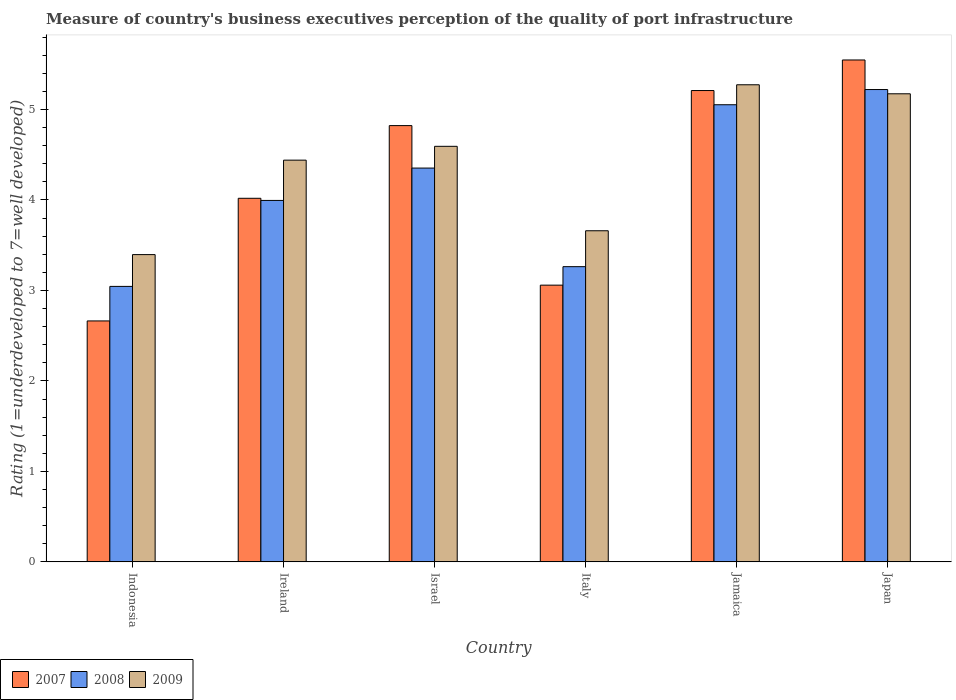How many different coloured bars are there?
Keep it short and to the point. 3. Are the number of bars on each tick of the X-axis equal?
Ensure brevity in your answer.  Yes. How many bars are there on the 3rd tick from the left?
Your answer should be very brief. 3. What is the ratings of the quality of port infrastructure in 2007 in Indonesia?
Offer a terse response. 2.66. Across all countries, what is the maximum ratings of the quality of port infrastructure in 2009?
Your response must be concise. 5.27. Across all countries, what is the minimum ratings of the quality of port infrastructure in 2009?
Make the answer very short. 3.4. In which country was the ratings of the quality of port infrastructure in 2009 maximum?
Your response must be concise. Jamaica. What is the total ratings of the quality of port infrastructure in 2009 in the graph?
Give a very brief answer. 26.54. What is the difference between the ratings of the quality of port infrastructure in 2007 in Indonesia and that in Japan?
Keep it short and to the point. -2.88. What is the difference between the ratings of the quality of port infrastructure in 2008 in Ireland and the ratings of the quality of port infrastructure in 2009 in Japan?
Provide a succinct answer. -1.18. What is the average ratings of the quality of port infrastructure in 2007 per country?
Your answer should be very brief. 4.22. What is the difference between the ratings of the quality of port infrastructure of/in 2008 and ratings of the quality of port infrastructure of/in 2009 in Jamaica?
Make the answer very short. -0.22. In how many countries, is the ratings of the quality of port infrastructure in 2009 greater than 3.6?
Provide a succinct answer. 5. What is the ratio of the ratings of the quality of port infrastructure in 2007 in Ireland to that in Japan?
Make the answer very short. 0.72. Is the difference between the ratings of the quality of port infrastructure in 2008 in Italy and Jamaica greater than the difference between the ratings of the quality of port infrastructure in 2009 in Italy and Jamaica?
Provide a succinct answer. No. What is the difference between the highest and the second highest ratings of the quality of port infrastructure in 2007?
Keep it short and to the point. 0.39. What is the difference between the highest and the lowest ratings of the quality of port infrastructure in 2009?
Give a very brief answer. 1.88. Is the sum of the ratings of the quality of port infrastructure in 2009 in Indonesia and Jamaica greater than the maximum ratings of the quality of port infrastructure in 2007 across all countries?
Offer a very short reply. Yes. What does the 2nd bar from the right in Japan represents?
Keep it short and to the point. 2008. How many bars are there?
Your answer should be very brief. 18. Are all the bars in the graph horizontal?
Provide a short and direct response. No. What is the difference between two consecutive major ticks on the Y-axis?
Offer a terse response. 1. Are the values on the major ticks of Y-axis written in scientific E-notation?
Your response must be concise. No. Does the graph contain grids?
Your response must be concise. No. Where does the legend appear in the graph?
Provide a succinct answer. Bottom left. How are the legend labels stacked?
Make the answer very short. Horizontal. What is the title of the graph?
Provide a succinct answer. Measure of country's business executives perception of the quality of port infrastructure. What is the label or title of the X-axis?
Make the answer very short. Country. What is the label or title of the Y-axis?
Ensure brevity in your answer.  Rating (1=underdeveloped to 7=well developed). What is the Rating (1=underdeveloped to 7=well developed) in 2007 in Indonesia?
Offer a terse response. 2.66. What is the Rating (1=underdeveloped to 7=well developed) in 2008 in Indonesia?
Provide a succinct answer. 3.04. What is the Rating (1=underdeveloped to 7=well developed) in 2009 in Indonesia?
Provide a succinct answer. 3.4. What is the Rating (1=underdeveloped to 7=well developed) of 2007 in Ireland?
Make the answer very short. 4.02. What is the Rating (1=underdeveloped to 7=well developed) of 2008 in Ireland?
Make the answer very short. 4. What is the Rating (1=underdeveloped to 7=well developed) of 2009 in Ireland?
Your response must be concise. 4.44. What is the Rating (1=underdeveloped to 7=well developed) of 2007 in Israel?
Offer a terse response. 4.82. What is the Rating (1=underdeveloped to 7=well developed) of 2008 in Israel?
Provide a short and direct response. 4.35. What is the Rating (1=underdeveloped to 7=well developed) in 2009 in Israel?
Your answer should be very brief. 4.59. What is the Rating (1=underdeveloped to 7=well developed) in 2007 in Italy?
Your response must be concise. 3.06. What is the Rating (1=underdeveloped to 7=well developed) of 2008 in Italy?
Your response must be concise. 3.26. What is the Rating (1=underdeveloped to 7=well developed) in 2009 in Italy?
Offer a terse response. 3.66. What is the Rating (1=underdeveloped to 7=well developed) in 2007 in Jamaica?
Provide a short and direct response. 5.21. What is the Rating (1=underdeveloped to 7=well developed) in 2008 in Jamaica?
Your answer should be compact. 5.05. What is the Rating (1=underdeveloped to 7=well developed) of 2009 in Jamaica?
Keep it short and to the point. 5.27. What is the Rating (1=underdeveloped to 7=well developed) of 2007 in Japan?
Keep it short and to the point. 5.55. What is the Rating (1=underdeveloped to 7=well developed) in 2008 in Japan?
Your answer should be compact. 5.22. What is the Rating (1=underdeveloped to 7=well developed) of 2009 in Japan?
Provide a succinct answer. 5.17. Across all countries, what is the maximum Rating (1=underdeveloped to 7=well developed) in 2007?
Make the answer very short. 5.55. Across all countries, what is the maximum Rating (1=underdeveloped to 7=well developed) of 2008?
Offer a terse response. 5.22. Across all countries, what is the maximum Rating (1=underdeveloped to 7=well developed) in 2009?
Offer a terse response. 5.27. Across all countries, what is the minimum Rating (1=underdeveloped to 7=well developed) of 2007?
Ensure brevity in your answer.  2.66. Across all countries, what is the minimum Rating (1=underdeveloped to 7=well developed) in 2008?
Keep it short and to the point. 3.04. Across all countries, what is the minimum Rating (1=underdeveloped to 7=well developed) in 2009?
Provide a short and direct response. 3.4. What is the total Rating (1=underdeveloped to 7=well developed) of 2007 in the graph?
Offer a terse response. 25.32. What is the total Rating (1=underdeveloped to 7=well developed) in 2008 in the graph?
Ensure brevity in your answer.  24.93. What is the total Rating (1=underdeveloped to 7=well developed) of 2009 in the graph?
Keep it short and to the point. 26.54. What is the difference between the Rating (1=underdeveloped to 7=well developed) in 2007 in Indonesia and that in Ireland?
Offer a very short reply. -1.36. What is the difference between the Rating (1=underdeveloped to 7=well developed) in 2008 in Indonesia and that in Ireland?
Give a very brief answer. -0.95. What is the difference between the Rating (1=underdeveloped to 7=well developed) of 2009 in Indonesia and that in Ireland?
Your response must be concise. -1.04. What is the difference between the Rating (1=underdeveloped to 7=well developed) of 2007 in Indonesia and that in Israel?
Your answer should be compact. -2.16. What is the difference between the Rating (1=underdeveloped to 7=well developed) in 2008 in Indonesia and that in Israel?
Provide a succinct answer. -1.31. What is the difference between the Rating (1=underdeveloped to 7=well developed) in 2009 in Indonesia and that in Israel?
Your response must be concise. -1.2. What is the difference between the Rating (1=underdeveloped to 7=well developed) of 2007 in Indonesia and that in Italy?
Offer a terse response. -0.4. What is the difference between the Rating (1=underdeveloped to 7=well developed) of 2008 in Indonesia and that in Italy?
Offer a very short reply. -0.22. What is the difference between the Rating (1=underdeveloped to 7=well developed) of 2009 in Indonesia and that in Italy?
Keep it short and to the point. -0.26. What is the difference between the Rating (1=underdeveloped to 7=well developed) of 2007 in Indonesia and that in Jamaica?
Provide a short and direct response. -2.55. What is the difference between the Rating (1=underdeveloped to 7=well developed) in 2008 in Indonesia and that in Jamaica?
Your answer should be compact. -2.01. What is the difference between the Rating (1=underdeveloped to 7=well developed) of 2009 in Indonesia and that in Jamaica?
Ensure brevity in your answer.  -1.88. What is the difference between the Rating (1=underdeveloped to 7=well developed) of 2007 in Indonesia and that in Japan?
Provide a succinct answer. -2.88. What is the difference between the Rating (1=underdeveloped to 7=well developed) of 2008 in Indonesia and that in Japan?
Make the answer very short. -2.18. What is the difference between the Rating (1=underdeveloped to 7=well developed) of 2009 in Indonesia and that in Japan?
Make the answer very short. -1.78. What is the difference between the Rating (1=underdeveloped to 7=well developed) in 2007 in Ireland and that in Israel?
Ensure brevity in your answer.  -0.8. What is the difference between the Rating (1=underdeveloped to 7=well developed) of 2008 in Ireland and that in Israel?
Give a very brief answer. -0.36. What is the difference between the Rating (1=underdeveloped to 7=well developed) of 2009 in Ireland and that in Israel?
Your answer should be very brief. -0.15. What is the difference between the Rating (1=underdeveloped to 7=well developed) of 2007 in Ireland and that in Italy?
Offer a terse response. 0.96. What is the difference between the Rating (1=underdeveloped to 7=well developed) of 2008 in Ireland and that in Italy?
Your answer should be very brief. 0.73. What is the difference between the Rating (1=underdeveloped to 7=well developed) in 2009 in Ireland and that in Italy?
Give a very brief answer. 0.78. What is the difference between the Rating (1=underdeveloped to 7=well developed) in 2007 in Ireland and that in Jamaica?
Your answer should be compact. -1.19. What is the difference between the Rating (1=underdeveloped to 7=well developed) in 2008 in Ireland and that in Jamaica?
Provide a succinct answer. -1.06. What is the difference between the Rating (1=underdeveloped to 7=well developed) of 2009 in Ireland and that in Jamaica?
Keep it short and to the point. -0.83. What is the difference between the Rating (1=underdeveloped to 7=well developed) in 2007 in Ireland and that in Japan?
Offer a terse response. -1.53. What is the difference between the Rating (1=underdeveloped to 7=well developed) of 2008 in Ireland and that in Japan?
Your response must be concise. -1.23. What is the difference between the Rating (1=underdeveloped to 7=well developed) of 2009 in Ireland and that in Japan?
Give a very brief answer. -0.73. What is the difference between the Rating (1=underdeveloped to 7=well developed) in 2007 in Israel and that in Italy?
Provide a short and direct response. 1.76. What is the difference between the Rating (1=underdeveloped to 7=well developed) of 2008 in Israel and that in Italy?
Your answer should be compact. 1.09. What is the difference between the Rating (1=underdeveloped to 7=well developed) in 2009 in Israel and that in Italy?
Your answer should be very brief. 0.93. What is the difference between the Rating (1=underdeveloped to 7=well developed) of 2007 in Israel and that in Jamaica?
Provide a succinct answer. -0.39. What is the difference between the Rating (1=underdeveloped to 7=well developed) of 2008 in Israel and that in Jamaica?
Ensure brevity in your answer.  -0.7. What is the difference between the Rating (1=underdeveloped to 7=well developed) in 2009 in Israel and that in Jamaica?
Your response must be concise. -0.68. What is the difference between the Rating (1=underdeveloped to 7=well developed) of 2007 in Israel and that in Japan?
Your response must be concise. -0.73. What is the difference between the Rating (1=underdeveloped to 7=well developed) of 2008 in Israel and that in Japan?
Keep it short and to the point. -0.87. What is the difference between the Rating (1=underdeveloped to 7=well developed) of 2009 in Israel and that in Japan?
Make the answer very short. -0.58. What is the difference between the Rating (1=underdeveloped to 7=well developed) of 2007 in Italy and that in Jamaica?
Provide a short and direct response. -2.15. What is the difference between the Rating (1=underdeveloped to 7=well developed) in 2008 in Italy and that in Jamaica?
Provide a short and direct response. -1.79. What is the difference between the Rating (1=underdeveloped to 7=well developed) of 2009 in Italy and that in Jamaica?
Your answer should be compact. -1.61. What is the difference between the Rating (1=underdeveloped to 7=well developed) in 2007 in Italy and that in Japan?
Make the answer very short. -2.49. What is the difference between the Rating (1=underdeveloped to 7=well developed) in 2008 in Italy and that in Japan?
Make the answer very short. -1.96. What is the difference between the Rating (1=underdeveloped to 7=well developed) in 2009 in Italy and that in Japan?
Offer a very short reply. -1.51. What is the difference between the Rating (1=underdeveloped to 7=well developed) in 2007 in Jamaica and that in Japan?
Provide a succinct answer. -0.34. What is the difference between the Rating (1=underdeveloped to 7=well developed) of 2008 in Jamaica and that in Japan?
Your response must be concise. -0.17. What is the difference between the Rating (1=underdeveloped to 7=well developed) of 2009 in Jamaica and that in Japan?
Offer a terse response. 0.1. What is the difference between the Rating (1=underdeveloped to 7=well developed) of 2007 in Indonesia and the Rating (1=underdeveloped to 7=well developed) of 2008 in Ireland?
Provide a succinct answer. -1.33. What is the difference between the Rating (1=underdeveloped to 7=well developed) of 2007 in Indonesia and the Rating (1=underdeveloped to 7=well developed) of 2009 in Ireland?
Your response must be concise. -1.78. What is the difference between the Rating (1=underdeveloped to 7=well developed) of 2008 in Indonesia and the Rating (1=underdeveloped to 7=well developed) of 2009 in Ireland?
Make the answer very short. -1.4. What is the difference between the Rating (1=underdeveloped to 7=well developed) in 2007 in Indonesia and the Rating (1=underdeveloped to 7=well developed) in 2008 in Israel?
Provide a short and direct response. -1.69. What is the difference between the Rating (1=underdeveloped to 7=well developed) of 2007 in Indonesia and the Rating (1=underdeveloped to 7=well developed) of 2009 in Israel?
Ensure brevity in your answer.  -1.93. What is the difference between the Rating (1=underdeveloped to 7=well developed) in 2008 in Indonesia and the Rating (1=underdeveloped to 7=well developed) in 2009 in Israel?
Give a very brief answer. -1.55. What is the difference between the Rating (1=underdeveloped to 7=well developed) of 2007 in Indonesia and the Rating (1=underdeveloped to 7=well developed) of 2008 in Italy?
Your answer should be very brief. -0.6. What is the difference between the Rating (1=underdeveloped to 7=well developed) in 2007 in Indonesia and the Rating (1=underdeveloped to 7=well developed) in 2009 in Italy?
Make the answer very short. -1. What is the difference between the Rating (1=underdeveloped to 7=well developed) of 2008 in Indonesia and the Rating (1=underdeveloped to 7=well developed) of 2009 in Italy?
Provide a succinct answer. -0.61. What is the difference between the Rating (1=underdeveloped to 7=well developed) of 2007 in Indonesia and the Rating (1=underdeveloped to 7=well developed) of 2008 in Jamaica?
Your answer should be very brief. -2.39. What is the difference between the Rating (1=underdeveloped to 7=well developed) in 2007 in Indonesia and the Rating (1=underdeveloped to 7=well developed) in 2009 in Jamaica?
Offer a terse response. -2.61. What is the difference between the Rating (1=underdeveloped to 7=well developed) of 2008 in Indonesia and the Rating (1=underdeveloped to 7=well developed) of 2009 in Jamaica?
Ensure brevity in your answer.  -2.23. What is the difference between the Rating (1=underdeveloped to 7=well developed) in 2007 in Indonesia and the Rating (1=underdeveloped to 7=well developed) in 2008 in Japan?
Your answer should be very brief. -2.56. What is the difference between the Rating (1=underdeveloped to 7=well developed) in 2007 in Indonesia and the Rating (1=underdeveloped to 7=well developed) in 2009 in Japan?
Provide a short and direct response. -2.51. What is the difference between the Rating (1=underdeveloped to 7=well developed) in 2008 in Indonesia and the Rating (1=underdeveloped to 7=well developed) in 2009 in Japan?
Provide a succinct answer. -2.13. What is the difference between the Rating (1=underdeveloped to 7=well developed) in 2007 in Ireland and the Rating (1=underdeveloped to 7=well developed) in 2008 in Israel?
Provide a short and direct response. -0.33. What is the difference between the Rating (1=underdeveloped to 7=well developed) of 2007 in Ireland and the Rating (1=underdeveloped to 7=well developed) of 2009 in Israel?
Offer a very short reply. -0.57. What is the difference between the Rating (1=underdeveloped to 7=well developed) in 2008 in Ireland and the Rating (1=underdeveloped to 7=well developed) in 2009 in Israel?
Offer a terse response. -0.6. What is the difference between the Rating (1=underdeveloped to 7=well developed) in 2007 in Ireland and the Rating (1=underdeveloped to 7=well developed) in 2008 in Italy?
Give a very brief answer. 0.76. What is the difference between the Rating (1=underdeveloped to 7=well developed) of 2007 in Ireland and the Rating (1=underdeveloped to 7=well developed) of 2009 in Italy?
Offer a terse response. 0.36. What is the difference between the Rating (1=underdeveloped to 7=well developed) of 2008 in Ireland and the Rating (1=underdeveloped to 7=well developed) of 2009 in Italy?
Your response must be concise. 0.34. What is the difference between the Rating (1=underdeveloped to 7=well developed) of 2007 in Ireland and the Rating (1=underdeveloped to 7=well developed) of 2008 in Jamaica?
Give a very brief answer. -1.03. What is the difference between the Rating (1=underdeveloped to 7=well developed) of 2007 in Ireland and the Rating (1=underdeveloped to 7=well developed) of 2009 in Jamaica?
Give a very brief answer. -1.25. What is the difference between the Rating (1=underdeveloped to 7=well developed) of 2008 in Ireland and the Rating (1=underdeveloped to 7=well developed) of 2009 in Jamaica?
Provide a short and direct response. -1.28. What is the difference between the Rating (1=underdeveloped to 7=well developed) of 2007 in Ireland and the Rating (1=underdeveloped to 7=well developed) of 2008 in Japan?
Provide a succinct answer. -1.2. What is the difference between the Rating (1=underdeveloped to 7=well developed) of 2007 in Ireland and the Rating (1=underdeveloped to 7=well developed) of 2009 in Japan?
Your answer should be very brief. -1.16. What is the difference between the Rating (1=underdeveloped to 7=well developed) of 2008 in Ireland and the Rating (1=underdeveloped to 7=well developed) of 2009 in Japan?
Keep it short and to the point. -1.18. What is the difference between the Rating (1=underdeveloped to 7=well developed) of 2007 in Israel and the Rating (1=underdeveloped to 7=well developed) of 2008 in Italy?
Ensure brevity in your answer.  1.56. What is the difference between the Rating (1=underdeveloped to 7=well developed) in 2007 in Israel and the Rating (1=underdeveloped to 7=well developed) in 2009 in Italy?
Provide a succinct answer. 1.16. What is the difference between the Rating (1=underdeveloped to 7=well developed) in 2008 in Israel and the Rating (1=underdeveloped to 7=well developed) in 2009 in Italy?
Your answer should be compact. 0.69. What is the difference between the Rating (1=underdeveloped to 7=well developed) of 2007 in Israel and the Rating (1=underdeveloped to 7=well developed) of 2008 in Jamaica?
Your answer should be compact. -0.23. What is the difference between the Rating (1=underdeveloped to 7=well developed) in 2007 in Israel and the Rating (1=underdeveloped to 7=well developed) in 2009 in Jamaica?
Your answer should be very brief. -0.45. What is the difference between the Rating (1=underdeveloped to 7=well developed) of 2008 in Israel and the Rating (1=underdeveloped to 7=well developed) of 2009 in Jamaica?
Provide a succinct answer. -0.92. What is the difference between the Rating (1=underdeveloped to 7=well developed) of 2007 in Israel and the Rating (1=underdeveloped to 7=well developed) of 2008 in Japan?
Your answer should be very brief. -0.4. What is the difference between the Rating (1=underdeveloped to 7=well developed) of 2007 in Israel and the Rating (1=underdeveloped to 7=well developed) of 2009 in Japan?
Provide a short and direct response. -0.35. What is the difference between the Rating (1=underdeveloped to 7=well developed) in 2008 in Israel and the Rating (1=underdeveloped to 7=well developed) in 2009 in Japan?
Make the answer very short. -0.82. What is the difference between the Rating (1=underdeveloped to 7=well developed) in 2007 in Italy and the Rating (1=underdeveloped to 7=well developed) in 2008 in Jamaica?
Give a very brief answer. -1.99. What is the difference between the Rating (1=underdeveloped to 7=well developed) of 2007 in Italy and the Rating (1=underdeveloped to 7=well developed) of 2009 in Jamaica?
Keep it short and to the point. -2.21. What is the difference between the Rating (1=underdeveloped to 7=well developed) of 2008 in Italy and the Rating (1=underdeveloped to 7=well developed) of 2009 in Jamaica?
Give a very brief answer. -2.01. What is the difference between the Rating (1=underdeveloped to 7=well developed) of 2007 in Italy and the Rating (1=underdeveloped to 7=well developed) of 2008 in Japan?
Offer a terse response. -2.16. What is the difference between the Rating (1=underdeveloped to 7=well developed) in 2007 in Italy and the Rating (1=underdeveloped to 7=well developed) in 2009 in Japan?
Make the answer very short. -2.12. What is the difference between the Rating (1=underdeveloped to 7=well developed) of 2008 in Italy and the Rating (1=underdeveloped to 7=well developed) of 2009 in Japan?
Offer a terse response. -1.91. What is the difference between the Rating (1=underdeveloped to 7=well developed) in 2007 in Jamaica and the Rating (1=underdeveloped to 7=well developed) in 2008 in Japan?
Offer a very short reply. -0.01. What is the difference between the Rating (1=underdeveloped to 7=well developed) of 2007 in Jamaica and the Rating (1=underdeveloped to 7=well developed) of 2009 in Japan?
Your answer should be compact. 0.04. What is the difference between the Rating (1=underdeveloped to 7=well developed) in 2008 in Jamaica and the Rating (1=underdeveloped to 7=well developed) in 2009 in Japan?
Your answer should be very brief. -0.12. What is the average Rating (1=underdeveloped to 7=well developed) of 2007 per country?
Your response must be concise. 4.22. What is the average Rating (1=underdeveloped to 7=well developed) of 2008 per country?
Offer a terse response. 4.15. What is the average Rating (1=underdeveloped to 7=well developed) in 2009 per country?
Offer a terse response. 4.42. What is the difference between the Rating (1=underdeveloped to 7=well developed) in 2007 and Rating (1=underdeveloped to 7=well developed) in 2008 in Indonesia?
Keep it short and to the point. -0.38. What is the difference between the Rating (1=underdeveloped to 7=well developed) of 2007 and Rating (1=underdeveloped to 7=well developed) of 2009 in Indonesia?
Keep it short and to the point. -0.73. What is the difference between the Rating (1=underdeveloped to 7=well developed) of 2008 and Rating (1=underdeveloped to 7=well developed) of 2009 in Indonesia?
Your answer should be very brief. -0.35. What is the difference between the Rating (1=underdeveloped to 7=well developed) in 2007 and Rating (1=underdeveloped to 7=well developed) in 2008 in Ireland?
Your answer should be compact. 0.02. What is the difference between the Rating (1=underdeveloped to 7=well developed) in 2007 and Rating (1=underdeveloped to 7=well developed) in 2009 in Ireland?
Offer a very short reply. -0.42. What is the difference between the Rating (1=underdeveloped to 7=well developed) in 2008 and Rating (1=underdeveloped to 7=well developed) in 2009 in Ireland?
Provide a short and direct response. -0.45. What is the difference between the Rating (1=underdeveloped to 7=well developed) of 2007 and Rating (1=underdeveloped to 7=well developed) of 2008 in Israel?
Ensure brevity in your answer.  0.47. What is the difference between the Rating (1=underdeveloped to 7=well developed) of 2007 and Rating (1=underdeveloped to 7=well developed) of 2009 in Israel?
Keep it short and to the point. 0.23. What is the difference between the Rating (1=underdeveloped to 7=well developed) of 2008 and Rating (1=underdeveloped to 7=well developed) of 2009 in Israel?
Provide a short and direct response. -0.24. What is the difference between the Rating (1=underdeveloped to 7=well developed) of 2007 and Rating (1=underdeveloped to 7=well developed) of 2008 in Italy?
Offer a very short reply. -0.2. What is the difference between the Rating (1=underdeveloped to 7=well developed) of 2007 and Rating (1=underdeveloped to 7=well developed) of 2009 in Italy?
Your answer should be very brief. -0.6. What is the difference between the Rating (1=underdeveloped to 7=well developed) of 2008 and Rating (1=underdeveloped to 7=well developed) of 2009 in Italy?
Your answer should be compact. -0.4. What is the difference between the Rating (1=underdeveloped to 7=well developed) of 2007 and Rating (1=underdeveloped to 7=well developed) of 2008 in Jamaica?
Make the answer very short. 0.16. What is the difference between the Rating (1=underdeveloped to 7=well developed) in 2007 and Rating (1=underdeveloped to 7=well developed) in 2009 in Jamaica?
Provide a short and direct response. -0.06. What is the difference between the Rating (1=underdeveloped to 7=well developed) of 2008 and Rating (1=underdeveloped to 7=well developed) of 2009 in Jamaica?
Ensure brevity in your answer.  -0.22. What is the difference between the Rating (1=underdeveloped to 7=well developed) in 2007 and Rating (1=underdeveloped to 7=well developed) in 2008 in Japan?
Make the answer very short. 0.33. What is the difference between the Rating (1=underdeveloped to 7=well developed) of 2007 and Rating (1=underdeveloped to 7=well developed) of 2009 in Japan?
Make the answer very short. 0.37. What is the difference between the Rating (1=underdeveloped to 7=well developed) in 2008 and Rating (1=underdeveloped to 7=well developed) in 2009 in Japan?
Your answer should be compact. 0.05. What is the ratio of the Rating (1=underdeveloped to 7=well developed) of 2007 in Indonesia to that in Ireland?
Make the answer very short. 0.66. What is the ratio of the Rating (1=underdeveloped to 7=well developed) in 2008 in Indonesia to that in Ireland?
Your answer should be very brief. 0.76. What is the ratio of the Rating (1=underdeveloped to 7=well developed) in 2009 in Indonesia to that in Ireland?
Provide a short and direct response. 0.76. What is the ratio of the Rating (1=underdeveloped to 7=well developed) in 2007 in Indonesia to that in Israel?
Provide a short and direct response. 0.55. What is the ratio of the Rating (1=underdeveloped to 7=well developed) in 2008 in Indonesia to that in Israel?
Provide a succinct answer. 0.7. What is the ratio of the Rating (1=underdeveloped to 7=well developed) in 2009 in Indonesia to that in Israel?
Your answer should be very brief. 0.74. What is the ratio of the Rating (1=underdeveloped to 7=well developed) in 2007 in Indonesia to that in Italy?
Your answer should be very brief. 0.87. What is the ratio of the Rating (1=underdeveloped to 7=well developed) of 2008 in Indonesia to that in Italy?
Your answer should be very brief. 0.93. What is the ratio of the Rating (1=underdeveloped to 7=well developed) in 2009 in Indonesia to that in Italy?
Your response must be concise. 0.93. What is the ratio of the Rating (1=underdeveloped to 7=well developed) of 2007 in Indonesia to that in Jamaica?
Your answer should be compact. 0.51. What is the ratio of the Rating (1=underdeveloped to 7=well developed) in 2008 in Indonesia to that in Jamaica?
Provide a succinct answer. 0.6. What is the ratio of the Rating (1=underdeveloped to 7=well developed) of 2009 in Indonesia to that in Jamaica?
Your answer should be very brief. 0.64. What is the ratio of the Rating (1=underdeveloped to 7=well developed) in 2007 in Indonesia to that in Japan?
Offer a terse response. 0.48. What is the ratio of the Rating (1=underdeveloped to 7=well developed) in 2008 in Indonesia to that in Japan?
Provide a short and direct response. 0.58. What is the ratio of the Rating (1=underdeveloped to 7=well developed) in 2009 in Indonesia to that in Japan?
Offer a very short reply. 0.66. What is the ratio of the Rating (1=underdeveloped to 7=well developed) in 2007 in Ireland to that in Israel?
Offer a terse response. 0.83. What is the ratio of the Rating (1=underdeveloped to 7=well developed) in 2008 in Ireland to that in Israel?
Make the answer very short. 0.92. What is the ratio of the Rating (1=underdeveloped to 7=well developed) of 2009 in Ireland to that in Israel?
Ensure brevity in your answer.  0.97. What is the ratio of the Rating (1=underdeveloped to 7=well developed) of 2007 in Ireland to that in Italy?
Keep it short and to the point. 1.31. What is the ratio of the Rating (1=underdeveloped to 7=well developed) of 2008 in Ireland to that in Italy?
Provide a succinct answer. 1.22. What is the ratio of the Rating (1=underdeveloped to 7=well developed) in 2009 in Ireland to that in Italy?
Your response must be concise. 1.21. What is the ratio of the Rating (1=underdeveloped to 7=well developed) in 2007 in Ireland to that in Jamaica?
Your response must be concise. 0.77. What is the ratio of the Rating (1=underdeveloped to 7=well developed) of 2008 in Ireland to that in Jamaica?
Your answer should be very brief. 0.79. What is the ratio of the Rating (1=underdeveloped to 7=well developed) of 2009 in Ireland to that in Jamaica?
Your answer should be very brief. 0.84. What is the ratio of the Rating (1=underdeveloped to 7=well developed) in 2007 in Ireland to that in Japan?
Your answer should be compact. 0.72. What is the ratio of the Rating (1=underdeveloped to 7=well developed) in 2008 in Ireland to that in Japan?
Ensure brevity in your answer.  0.77. What is the ratio of the Rating (1=underdeveloped to 7=well developed) in 2009 in Ireland to that in Japan?
Ensure brevity in your answer.  0.86. What is the ratio of the Rating (1=underdeveloped to 7=well developed) of 2007 in Israel to that in Italy?
Ensure brevity in your answer.  1.58. What is the ratio of the Rating (1=underdeveloped to 7=well developed) of 2008 in Israel to that in Italy?
Provide a short and direct response. 1.33. What is the ratio of the Rating (1=underdeveloped to 7=well developed) in 2009 in Israel to that in Italy?
Your answer should be compact. 1.25. What is the ratio of the Rating (1=underdeveloped to 7=well developed) of 2007 in Israel to that in Jamaica?
Keep it short and to the point. 0.93. What is the ratio of the Rating (1=underdeveloped to 7=well developed) in 2008 in Israel to that in Jamaica?
Your answer should be compact. 0.86. What is the ratio of the Rating (1=underdeveloped to 7=well developed) in 2009 in Israel to that in Jamaica?
Provide a succinct answer. 0.87. What is the ratio of the Rating (1=underdeveloped to 7=well developed) in 2007 in Israel to that in Japan?
Provide a short and direct response. 0.87. What is the ratio of the Rating (1=underdeveloped to 7=well developed) in 2008 in Israel to that in Japan?
Keep it short and to the point. 0.83. What is the ratio of the Rating (1=underdeveloped to 7=well developed) of 2009 in Israel to that in Japan?
Provide a succinct answer. 0.89. What is the ratio of the Rating (1=underdeveloped to 7=well developed) of 2007 in Italy to that in Jamaica?
Keep it short and to the point. 0.59. What is the ratio of the Rating (1=underdeveloped to 7=well developed) in 2008 in Italy to that in Jamaica?
Your answer should be very brief. 0.65. What is the ratio of the Rating (1=underdeveloped to 7=well developed) of 2009 in Italy to that in Jamaica?
Keep it short and to the point. 0.69. What is the ratio of the Rating (1=underdeveloped to 7=well developed) in 2007 in Italy to that in Japan?
Offer a terse response. 0.55. What is the ratio of the Rating (1=underdeveloped to 7=well developed) in 2009 in Italy to that in Japan?
Give a very brief answer. 0.71. What is the ratio of the Rating (1=underdeveloped to 7=well developed) of 2007 in Jamaica to that in Japan?
Your response must be concise. 0.94. What is the ratio of the Rating (1=underdeveloped to 7=well developed) of 2008 in Jamaica to that in Japan?
Make the answer very short. 0.97. What is the ratio of the Rating (1=underdeveloped to 7=well developed) in 2009 in Jamaica to that in Japan?
Ensure brevity in your answer.  1.02. What is the difference between the highest and the second highest Rating (1=underdeveloped to 7=well developed) of 2007?
Your answer should be compact. 0.34. What is the difference between the highest and the second highest Rating (1=underdeveloped to 7=well developed) in 2008?
Your response must be concise. 0.17. What is the difference between the highest and the second highest Rating (1=underdeveloped to 7=well developed) of 2009?
Offer a terse response. 0.1. What is the difference between the highest and the lowest Rating (1=underdeveloped to 7=well developed) in 2007?
Keep it short and to the point. 2.88. What is the difference between the highest and the lowest Rating (1=underdeveloped to 7=well developed) of 2008?
Your answer should be compact. 2.18. What is the difference between the highest and the lowest Rating (1=underdeveloped to 7=well developed) of 2009?
Your answer should be compact. 1.88. 